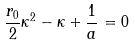<formula> <loc_0><loc_0><loc_500><loc_500>\frac { r _ { 0 } } { 2 } \kappa ^ { 2 } - \kappa + \frac { 1 } { a } = 0</formula> 